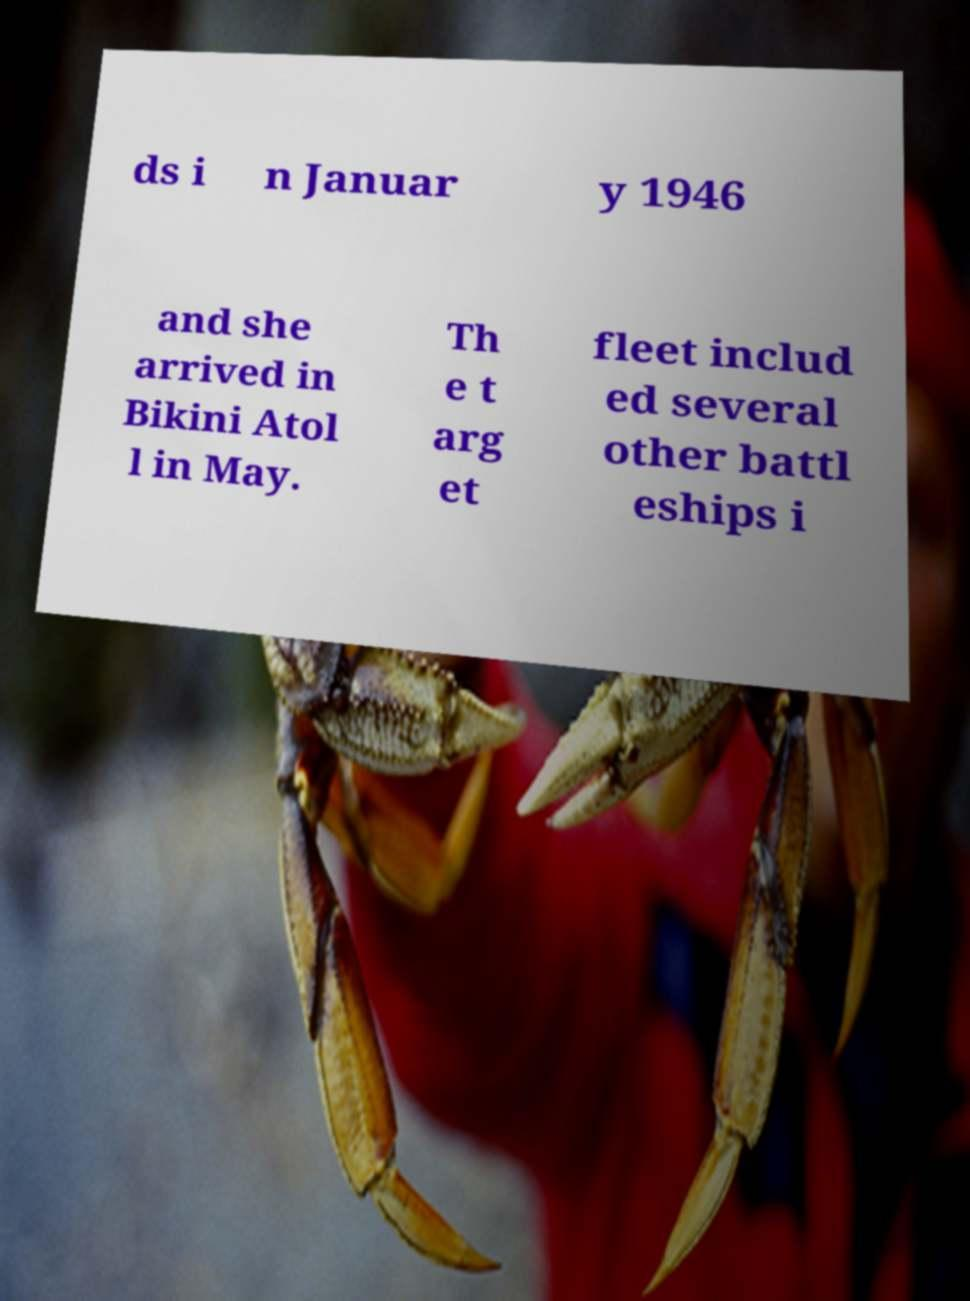What messages or text are displayed in this image? I need them in a readable, typed format. ds i n Januar y 1946 and she arrived in Bikini Atol l in May. Th e t arg et fleet includ ed several other battl eships i 